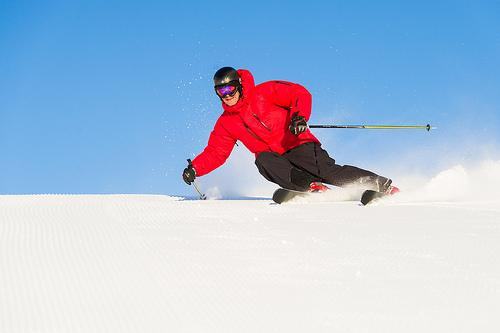What equipment is the skier using to ski and in what colors? The skier is using black and yellow ski poles, a black pair of skis, and wearing purple ski goggles. Based on the image, depict the weather conditions for skiing. The weather appears favorable for skiing, with a sunny day and a snowy ground. What is the primary focus of this image and the action it depicts? The main focus is a man skiing on snow, wearing a red sweatshirt and black pants, skiing fast and leaning to steer. Describe the weather and landscape in the image. The image features a clear blue sky above and a snowy ground covered with white snow below. Count and give a brief explanation of objects related to the man skiing. There are several objects related to the man skiing, including skis, ski poles, helmet, goggles, gloves, a red coat, and black pants. Describe any evident skiing techniques used by the subject in the image. The skier is leaning to the side to steer and appears to be moving quickly through the snow. Identify any distinct features in the skier's outfit. Distinct features include the red hoodie with drawstrings, purple ski goggles, black gloves, and black ski pants. In what physical condition does the snow appear to be in this image? The snow appears to be white and in powdered condition, with some being stirred up behind the skier. Determine the color and type of clothes worn by the skier. The skier is wearing a red hoodie, black ski pants, purple ski goggles, and a skiing helmet. Mention the key accessories the skier is using to protect themselves. The key protective accessories for the skier are purple ski goggles, skiing helmet, and gloves. Find the green tree next to the skier. There is no mention of a tree in the captions provided, and therefore it is not present in the image. Notice the dog playing happily in the snow nearby. There is no mention of a dog in any of the given captions, emphasizing that there is no dog in the image. Can you spot the snowboarder who is racing with the skier? There is no mention of a snowboarder or a race in any of the provided captions, and therefore it is misleading to ask for it. Examine the cabin at the bottom of the ski slope behind the man skiing. There is no mention of a cabin or ski slope in any of the given captions, suggesting that this object is not present in the image. Can you identify the chairlift moving up the mountain next to the skier? There is no mention of a chairlift or mountain in any of the provided captions, which makes the statement misleading. Observe the group of people cheering in the background for the skier. None of the captions indicate that there is a group of people cheering in the background. Thus, that statement is likely false. 